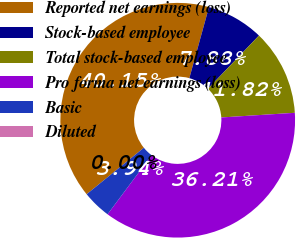Convert chart to OTSL. <chart><loc_0><loc_0><loc_500><loc_500><pie_chart><fcel>Reported net earnings (loss)<fcel>Stock-based employee<fcel>Total stock-based employee<fcel>Pro forma net earnings (loss)<fcel>Basic<fcel>Diluted<nl><fcel>40.15%<fcel>7.88%<fcel>11.82%<fcel>36.21%<fcel>3.94%<fcel>0.0%<nl></chart> 